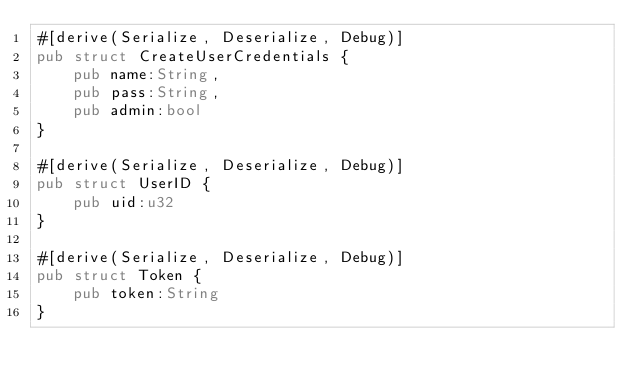<code> <loc_0><loc_0><loc_500><loc_500><_Rust_>#[derive(Serialize, Deserialize, Debug)]
pub struct CreateUserCredentials {
    pub name:String,
    pub pass:String,
    pub admin:bool
}

#[derive(Serialize, Deserialize, Debug)]
pub struct UserID {
    pub uid:u32
}

#[derive(Serialize, Deserialize, Debug)]
pub struct Token {
    pub token:String
}
</code> 